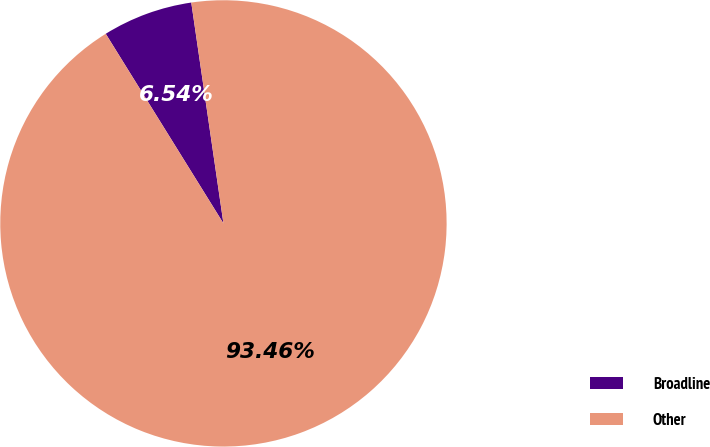Convert chart. <chart><loc_0><loc_0><loc_500><loc_500><pie_chart><fcel>Broadline<fcel>Other<nl><fcel>6.54%<fcel>93.46%<nl></chart> 